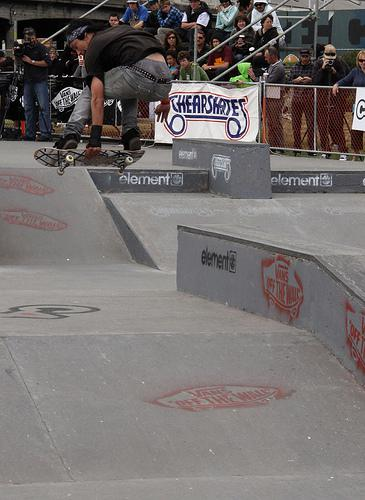Question: what color are the ramps?
Choices:
A. Gray.
B. Brown.
C. Black.
D. White.
Answer with the letter. Answer: A Question: what kind of pants is the skateboarder wearing?
Choices:
A. Canvas.
B. Cargo.
C. Jeans.
D. Cotton.
Answer with the letter. Answer: C Question: how many wheels does the skateboard have?
Choices:
A. Five.
B. Two.
C. Four.
D. Three.
Answer with the letter. Answer: C Question: what type of event is going on?
Choices:
A. Skateboarding.
B. Surfing.
C. Scrabble.
D. Dinner.
Answer with the letter. Answer: A Question: what color is the skateboarder's t-shirt?
Choices:
A. Purple.
B. Green.
C. Black.
D. Yellow.
Answer with the letter. Answer: C 